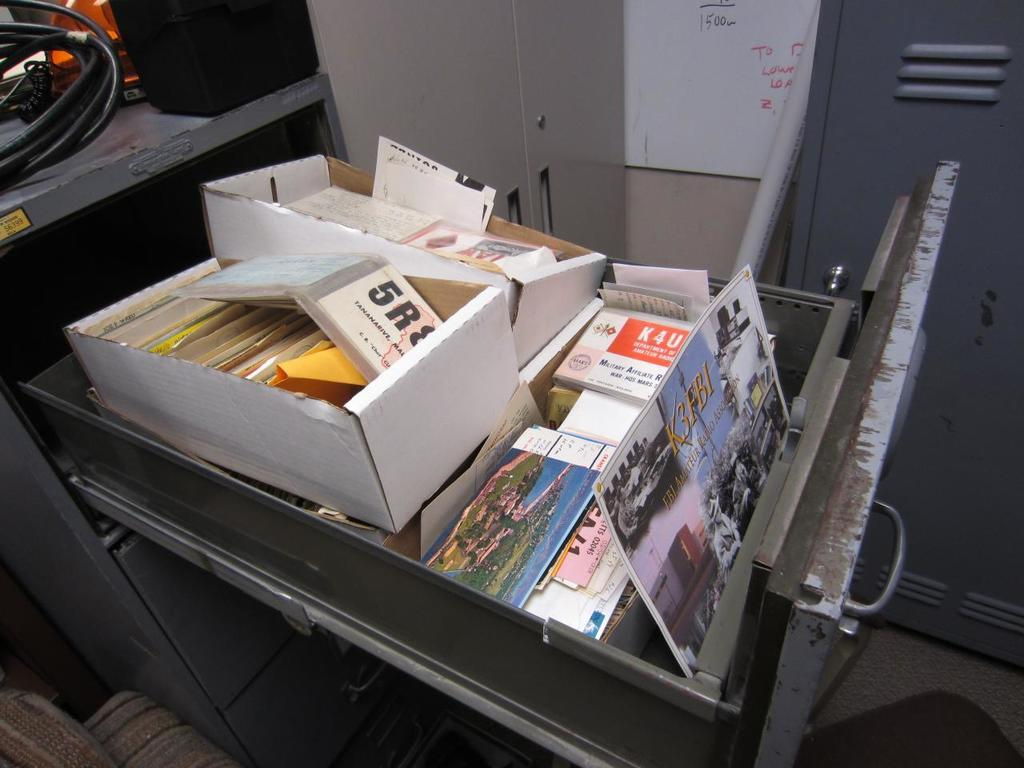<image>
Provide a brief description of the given image. the number 5 is on one of the light books 